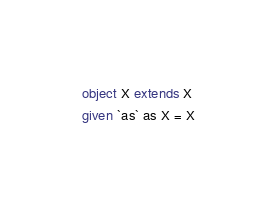<code> <loc_0><loc_0><loc_500><loc_500><_Scala_>object X extends X
given `as` as X = X</code> 